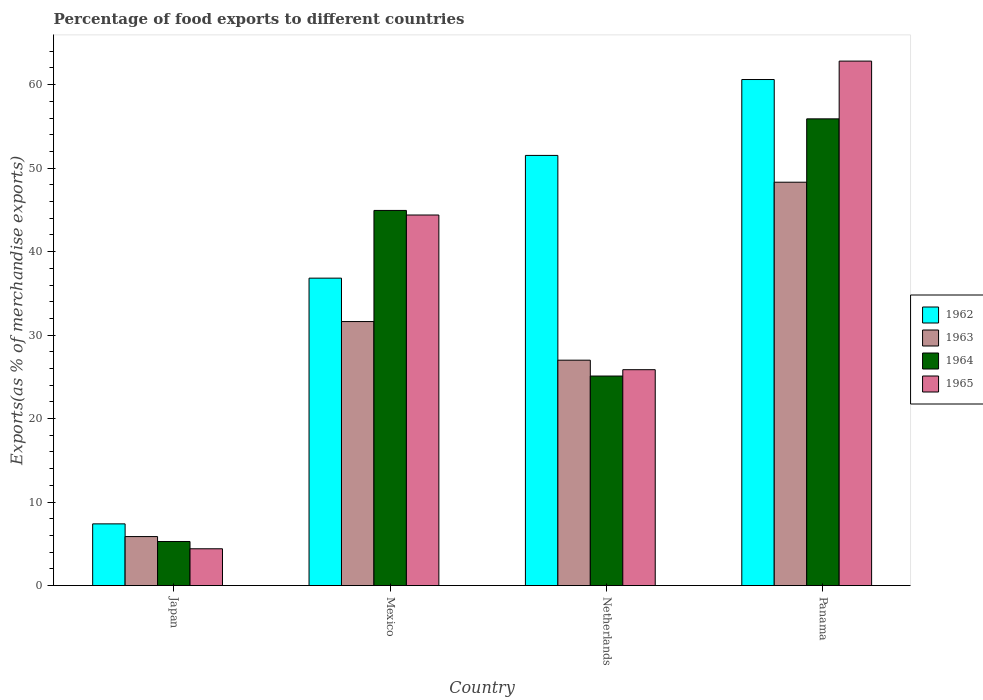Are the number of bars per tick equal to the number of legend labels?
Your answer should be compact. Yes. How many bars are there on the 4th tick from the left?
Keep it short and to the point. 4. In how many cases, is the number of bars for a given country not equal to the number of legend labels?
Offer a very short reply. 0. What is the percentage of exports to different countries in 1964 in Panama?
Your answer should be compact. 55.9. Across all countries, what is the maximum percentage of exports to different countries in 1965?
Offer a terse response. 62.82. Across all countries, what is the minimum percentage of exports to different countries in 1962?
Provide a succinct answer. 7.39. In which country was the percentage of exports to different countries in 1965 maximum?
Provide a short and direct response. Panama. What is the total percentage of exports to different countries in 1963 in the graph?
Your answer should be compact. 112.81. What is the difference between the percentage of exports to different countries in 1964 in Mexico and that in Panama?
Make the answer very short. -10.97. What is the difference between the percentage of exports to different countries in 1962 in Japan and the percentage of exports to different countries in 1964 in Mexico?
Give a very brief answer. -37.55. What is the average percentage of exports to different countries in 1965 per country?
Offer a terse response. 34.37. What is the difference between the percentage of exports to different countries of/in 1963 and percentage of exports to different countries of/in 1964 in Mexico?
Ensure brevity in your answer.  -13.31. What is the ratio of the percentage of exports to different countries in 1963 in Japan to that in Mexico?
Keep it short and to the point. 0.19. What is the difference between the highest and the second highest percentage of exports to different countries in 1962?
Keep it short and to the point. -9.09. What is the difference between the highest and the lowest percentage of exports to different countries in 1965?
Your answer should be very brief. 58.42. Is the sum of the percentage of exports to different countries in 1964 in Japan and Panama greater than the maximum percentage of exports to different countries in 1962 across all countries?
Ensure brevity in your answer.  Yes. Is it the case that in every country, the sum of the percentage of exports to different countries in 1964 and percentage of exports to different countries in 1962 is greater than the sum of percentage of exports to different countries in 1963 and percentage of exports to different countries in 1965?
Keep it short and to the point. No. What does the 3rd bar from the left in Netherlands represents?
Your answer should be compact. 1964. What does the 2nd bar from the right in Mexico represents?
Offer a very short reply. 1964. Is it the case that in every country, the sum of the percentage of exports to different countries in 1964 and percentage of exports to different countries in 1963 is greater than the percentage of exports to different countries in 1962?
Offer a very short reply. Yes. How many bars are there?
Provide a short and direct response. 16. Are all the bars in the graph horizontal?
Give a very brief answer. No. How many countries are there in the graph?
Offer a very short reply. 4. Are the values on the major ticks of Y-axis written in scientific E-notation?
Make the answer very short. No. Does the graph contain any zero values?
Make the answer very short. No. Where does the legend appear in the graph?
Offer a terse response. Center right. How many legend labels are there?
Your response must be concise. 4. What is the title of the graph?
Provide a short and direct response. Percentage of food exports to different countries. What is the label or title of the Y-axis?
Keep it short and to the point. Exports(as % of merchandise exports). What is the Exports(as % of merchandise exports) in 1962 in Japan?
Offer a very short reply. 7.39. What is the Exports(as % of merchandise exports) of 1963 in Japan?
Your answer should be compact. 5.87. What is the Exports(as % of merchandise exports) in 1964 in Japan?
Make the answer very short. 5.28. What is the Exports(as % of merchandise exports) in 1965 in Japan?
Provide a short and direct response. 4.41. What is the Exports(as % of merchandise exports) of 1962 in Mexico?
Your answer should be very brief. 36.82. What is the Exports(as % of merchandise exports) of 1963 in Mexico?
Ensure brevity in your answer.  31.62. What is the Exports(as % of merchandise exports) of 1964 in Mexico?
Keep it short and to the point. 44.93. What is the Exports(as % of merchandise exports) of 1965 in Mexico?
Keep it short and to the point. 44.39. What is the Exports(as % of merchandise exports) of 1962 in Netherlands?
Your answer should be very brief. 51.52. What is the Exports(as % of merchandise exports) of 1963 in Netherlands?
Offer a terse response. 27. What is the Exports(as % of merchandise exports) in 1964 in Netherlands?
Make the answer very short. 25.1. What is the Exports(as % of merchandise exports) in 1965 in Netherlands?
Keep it short and to the point. 25.86. What is the Exports(as % of merchandise exports) in 1962 in Panama?
Make the answer very short. 60.62. What is the Exports(as % of merchandise exports) in 1963 in Panama?
Your response must be concise. 48.32. What is the Exports(as % of merchandise exports) in 1964 in Panama?
Provide a short and direct response. 55.9. What is the Exports(as % of merchandise exports) in 1965 in Panama?
Give a very brief answer. 62.82. Across all countries, what is the maximum Exports(as % of merchandise exports) of 1962?
Make the answer very short. 60.62. Across all countries, what is the maximum Exports(as % of merchandise exports) of 1963?
Make the answer very short. 48.32. Across all countries, what is the maximum Exports(as % of merchandise exports) in 1964?
Keep it short and to the point. 55.9. Across all countries, what is the maximum Exports(as % of merchandise exports) in 1965?
Keep it short and to the point. 62.82. Across all countries, what is the minimum Exports(as % of merchandise exports) of 1962?
Your response must be concise. 7.39. Across all countries, what is the minimum Exports(as % of merchandise exports) of 1963?
Make the answer very short. 5.87. Across all countries, what is the minimum Exports(as % of merchandise exports) of 1964?
Give a very brief answer. 5.28. Across all countries, what is the minimum Exports(as % of merchandise exports) in 1965?
Provide a short and direct response. 4.41. What is the total Exports(as % of merchandise exports) in 1962 in the graph?
Provide a succinct answer. 156.35. What is the total Exports(as % of merchandise exports) in 1963 in the graph?
Offer a very short reply. 112.81. What is the total Exports(as % of merchandise exports) of 1964 in the graph?
Provide a short and direct response. 131.22. What is the total Exports(as % of merchandise exports) in 1965 in the graph?
Provide a short and direct response. 137.47. What is the difference between the Exports(as % of merchandise exports) of 1962 in Japan and that in Mexico?
Offer a very short reply. -29.43. What is the difference between the Exports(as % of merchandise exports) of 1963 in Japan and that in Mexico?
Your response must be concise. -25.75. What is the difference between the Exports(as % of merchandise exports) of 1964 in Japan and that in Mexico?
Your answer should be very brief. -39.66. What is the difference between the Exports(as % of merchandise exports) of 1965 in Japan and that in Mexico?
Provide a succinct answer. -39.98. What is the difference between the Exports(as % of merchandise exports) of 1962 in Japan and that in Netherlands?
Give a very brief answer. -44.13. What is the difference between the Exports(as % of merchandise exports) in 1963 in Japan and that in Netherlands?
Your answer should be very brief. -21.13. What is the difference between the Exports(as % of merchandise exports) of 1964 in Japan and that in Netherlands?
Ensure brevity in your answer.  -19.82. What is the difference between the Exports(as % of merchandise exports) of 1965 in Japan and that in Netherlands?
Your response must be concise. -21.45. What is the difference between the Exports(as % of merchandise exports) of 1962 in Japan and that in Panama?
Your answer should be very brief. -53.23. What is the difference between the Exports(as % of merchandise exports) of 1963 in Japan and that in Panama?
Your answer should be very brief. -42.45. What is the difference between the Exports(as % of merchandise exports) in 1964 in Japan and that in Panama?
Your answer should be very brief. -50.63. What is the difference between the Exports(as % of merchandise exports) in 1965 in Japan and that in Panama?
Give a very brief answer. -58.42. What is the difference between the Exports(as % of merchandise exports) of 1962 in Mexico and that in Netherlands?
Provide a succinct answer. -14.7. What is the difference between the Exports(as % of merchandise exports) in 1963 in Mexico and that in Netherlands?
Your answer should be very brief. 4.63. What is the difference between the Exports(as % of merchandise exports) of 1964 in Mexico and that in Netherlands?
Your response must be concise. 19.84. What is the difference between the Exports(as % of merchandise exports) of 1965 in Mexico and that in Netherlands?
Your answer should be compact. 18.53. What is the difference between the Exports(as % of merchandise exports) of 1962 in Mexico and that in Panama?
Keep it short and to the point. -23.79. What is the difference between the Exports(as % of merchandise exports) of 1963 in Mexico and that in Panama?
Your response must be concise. -16.69. What is the difference between the Exports(as % of merchandise exports) in 1964 in Mexico and that in Panama?
Your answer should be very brief. -10.97. What is the difference between the Exports(as % of merchandise exports) in 1965 in Mexico and that in Panama?
Your answer should be compact. -18.44. What is the difference between the Exports(as % of merchandise exports) in 1962 in Netherlands and that in Panama?
Your answer should be very brief. -9.09. What is the difference between the Exports(as % of merchandise exports) of 1963 in Netherlands and that in Panama?
Offer a very short reply. -21.32. What is the difference between the Exports(as % of merchandise exports) in 1964 in Netherlands and that in Panama?
Give a very brief answer. -30.81. What is the difference between the Exports(as % of merchandise exports) in 1965 in Netherlands and that in Panama?
Give a very brief answer. -36.96. What is the difference between the Exports(as % of merchandise exports) of 1962 in Japan and the Exports(as % of merchandise exports) of 1963 in Mexico?
Provide a succinct answer. -24.23. What is the difference between the Exports(as % of merchandise exports) of 1962 in Japan and the Exports(as % of merchandise exports) of 1964 in Mexico?
Your response must be concise. -37.55. What is the difference between the Exports(as % of merchandise exports) of 1962 in Japan and the Exports(as % of merchandise exports) of 1965 in Mexico?
Ensure brevity in your answer.  -37. What is the difference between the Exports(as % of merchandise exports) of 1963 in Japan and the Exports(as % of merchandise exports) of 1964 in Mexico?
Your answer should be very brief. -39.07. What is the difference between the Exports(as % of merchandise exports) of 1963 in Japan and the Exports(as % of merchandise exports) of 1965 in Mexico?
Offer a terse response. -38.52. What is the difference between the Exports(as % of merchandise exports) in 1964 in Japan and the Exports(as % of merchandise exports) in 1965 in Mexico?
Offer a terse response. -39.11. What is the difference between the Exports(as % of merchandise exports) of 1962 in Japan and the Exports(as % of merchandise exports) of 1963 in Netherlands?
Offer a terse response. -19.61. What is the difference between the Exports(as % of merchandise exports) in 1962 in Japan and the Exports(as % of merchandise exports) in 1964 in Netherlands?
Provide a succinct answer. -17.71. What is the difference between the Exports(as % of merchandise exports) in 1962 in Japan and the Exports(as % of merchandise exports) in 1965 in Netherlands?
Give a very brief answer. -18.47. What is the difference between the Exports(as % of merchandise exports) in 1963 in Japan and the Exports(as % of merchandise exports) in 1964 in Netherlands?
Keep it short and to the point. -19.23. What is the difference between the Exports(as % of merchandise exports) of 1963 in Japan and the Exports(as % of merchandise exports) of 1965 in Netherlands?
Provide a short and direct response. -19.99. What is the difference between the Exports(as % of merchandise exports) in 1964 in Japan and the Exports(as % of merchandise exports) in 1965 in Netherlands?
Your answer should be compact. -20.58. What is the difference between the Exports(as % of merchandise exports) of 1962 in Japan and the Exports(as % of merchandise exports) of 1963 in Panama?
Give a very brief answer. -40.93. What is the difference between the Exports(as % of merchandise exports) of 1962 in Japan and the Exports(as % of merchandise exports) of 1964 in Panama?
Make the answer very short. -48.51. What is the difference between the Exports(as % of merchandise exports) of 1962 in Japan and the Exports(as % of merchandise exports) of 1965 in Panama?
Offer a very short reply. -55.43. What is the difference between the Exports(as % of merchandise exports) of 1963 in Japan and the Exports(as % of merchandise exports) of 1964 in Panama?
Ensure brevity in your answer.  -50.03. What is the difference between the Exports(as % of merchandise exports) in 1963 in Japan and the Exports(as % of merchandise exports) in 1965 in Panama?
Provide a succinct answer. -56.95. What is the difference between the Exports(as % of merchandise exports) of 1964 in Japan and the Exports(as % of merchandise exports) of 1965 in Panama?
Your response must be concise. -57.54. What is the difference between the Exports(as % of merchandise exports) in 1962 in Mexico and the Exports(as % of merchandise exports) in 1963 in Netherlands?
Give a very brief answer. 9.83. What is the difference between the Exports(as % of merchandise exports) in 1962 in Mexico and the Exports(as % of merchandise exports) in 1964 in Netherlands?
Your answer should be very brief. 11.72. What is the difference between the Exports(as % of merchandise exports) of 1962 in Mexico and the Exports(as % of merchandise exports) of 1965 in Netherlands?
Your answer should be compact. 10.96. What is the difference between the Exports(as % of merchandise exports) of 1963 in Mexico and the Exports(as % of merchandise exports) of 1964 in Netherlands?
Make the answer very short. 6.53. What is the difference between the Exports(as % of merchandise exports) in 1963 in Mexico and the Exports(as % of merchandise exports) in 1965 in Netherlands?
Offer a terse response. 5.77. What is the difference between the Exports(as % of merchandise exports) of 1964 in Mexico and the Exports(as % of merchandise exports) of 1965 in Netherlands?
Your response must be concise. 19.08. What is the difference between the Exports(as % of merchandise exports) of 1962 in Mexico and the Exports(as % of merchandise exports) of 1963 in Panama?
Keep it short and to the point. -11.49. What is the difference between the Exports(as % of merchandise exports) of 1962 in Mexico and the Exports(as % of merchandise exports) of 1964 in Panama?
Provide a succinct answer. -19.08. What is the difference between the Exports(as % of merchandise exports) in 1962 in Mexico and the Exports(as % of merchandise exports) in 1965 in Panama?
Your answer should be very brief. -26. What is the difference between the Exports(as % of merchandise exports) in 1963 in Mexico and the Exports(as % of merchandise exports) in 1964 in Panama?
Offer a terse response. -24.28. What is the difference between the Exports(as % of merchandise exports) in 1963 in Mexico and the Exports(as % of merchandise exports) in 1965 in Panama?
Offer a very short reply. -31.2. What is the difference between the Exports(as % of merchandise exports) in 1964 in Mexico and the Exports(as % of merchandise exports) in 1965 in Panama?
Your response must be concise. -17.89. What is the difference between the Exports(as % of merchandise exports) of 1962 in Netherlands and the Exports(as % of merchandise exports) of 1963 in Panama?
Keep it short and to the point. 3.21. What is the difference between the Exports(as % of merchandise exports) in 1962 in Netherlands and the Exports(as % of merchandise exports) in 1964 in Panama?
Your answer should be very brief. -4.38. What is the difference between the Exports(as % of merchandise exports) in 1962 in Netherlands and the Exports(as % of merchandise exports) in 1965 in Panama?
Give a very brief answer. -11.3. What is the difference between the Exports(as % of merchandise exports) in 1963 in Netherlands and the Exports(as % of merchandise exports) in 1964 in Panama?
Provide a succinct answer. -28.91. What is the difference between the Exports(as % of merchandise exports) of 1963 in Netherlands and the Exports(as % of merchandise exports) of 1965 in Panama?
Offer a terse response. -35.82. What is the difference between the Exports(as % of merchandise exports) in 1964 in Netherlands and the Exports(as % of merchandise exports) in 1965 in Panama?
Provide a short and direct response. -37.72. What is the average Exports(as % of merchandise exports) in 1962 per country?
Offer a terse response. 39.09. What is the average Exports(as % of merchandise exports) in 1963 per country?
Provide a succinct answer. 28.2. What is the average Exports(as % of merchandise exports) in 1964 per country?
Keep it short and to the point. 32.8. What is the average Exports(as % of merchandise exports) of 1965 per country?
Your answer should be compact. 34.37. What is the difference between the Exports(as % of merchandise exports) in 1962 and Exports(as % of merchandise exports) in 1963 in Japan?
Keep it short and to the point. 1.52. What is the difference between the Exports(as % of merchandise exports) of 1962 and Exports(as % of merchandise exports) of 1964 in Japan?
Your answer should be compact. 2.11. What is the difference between the Exports(as % of merchandise exports) in 1962 and Exports(as % of merchandise exports) in 1965 in Japan?
Provide a short and direct response. 2.98. What is the difference between the Exports(as % of merchandise exports) of 1963 and Exports(as % of merchandise exports) of 1964 in Japan?
Give a very brief answer. 0.59. What is the difference between the Exports(as % of merchandise exports) of 1963 and Exports(as % of merchandise exports) of 1965 in Japan?
Offer a terse response. 1.46. What is the difference between the Exports(as % of merchandise exports) of 1964 and Exports(as % of merchandise exports) of 1965 in Japan?
Ensure brevity in your answer.  0.87. What is the difference between the Exports(as % of merchandise exports) of 1962 and Exports(as % of merchandise exports) of 1963 in Mexico?
Keep it short and to the point. 5.2. What is the difference between the Exports(as % of merchandise exports) in 1962 and Exports(as % of merchandise exports) in 1964 in Mexico?
Provide a short and direct response. -8.11. What is the difference between the Exports(as % of merchandise exports) of 1962 and Exports(as % of merchandise exports) of 1965 in Mexico?
Your answer should be very brief. -7.56. What is the difference between the Exports(as % of merchandise exports) in 1963 and Exports(as % of merchandise exports) in 1964 in Mexico?
Provide a short and direct response. -13.31. What is the difference between the Exports(as % of merchandise exports) of 1963 and Exports(as % of merchandise exports) of 1965 in Mexico?
Offer a terse response. -12.76. What is the difference between the Exports(as % of merchandise exports) in 1964 and Exports(as % of merchandise exports) in 1965 in Mexico?
Your answer should be compact. 0.55. What is the difference between the Exports(as % of merchandise exports) of 1962 and Exports(as % of merchandise exports) of 1963 in Netherlands?
Give a very brief answer. 24.53. What is the difference between the Exports(as % of merchandise exports) of 1962 and Exports(as % of merchandise exports) of 1964 in Netherlands?
Provide a succinct answer. 26.43. What is the difference between the Exports(as % of merchandise exports) of 1962 and Exports(as % of merchandise exports) of 1965 in Netherlands?
Your answer should be compact. 25.67. What is the difference between the Exports(as % of merchandise exports) of 1963 and Exports(as % of merchandise exports) of 1964 in Netherlands?
Your response must be concise. 1.9. What is the difference between the Exports(as % of merchandise exports) in 1963 and Exports(as % of merchandise exports) in 1965 in Netherlands?
Offer a very short reply. 1.14. What is the difference between the Exports(as % of merchandise exports) of 1964 and Exports(as % of merchandise exports) of 1965 in Netherlands?
Make the answer very short. -0.76. What is the difference between the Exports(as % of merchandise exports) of 1962 and Exports(as % of merchandise exports) of 1963 in Panama?
Offer a terse response. 12.3. What is the difference between the Exports(as % of merchandise exports) in 1962 and Exports(as % of merchandise exports) in 1964 in Panama?
Give a very brief answer. 4.71. What is the difference between the Exports(as % of merchandise exports) of 1962 and Exports(as % of merchandise exports) of 1965 in Panama?
Offer a very short reply. -2.21. What is the difference between the Exports(as % of merchandise exports) in 1963 and Exports(as % of merchandise exports) in 1964 in Panama?
Keep it short and to the point. -7.59. What is the difference between the Exports(as % of merchandise exports) of 1963 and Exports(as % of merchandise exports) of 1965 in Panama?
Offer a very short reply. -14.51. What is the difference between the Exports(as % of merchandise exports) in 1964 and Exports(as % of merchandise exports) in 1965 in Panama?
Your answer should be compact. -6.92. What is the ratio of the Exports(as % of merchandise exports) of 1962 in Japan to that in Mexico?
Give a very brief answer. 0.2. What is the ratio of the Exports(as % of merchandise exports) in 1963 in Japan to that in Mexico?
Your response must be concise. 0.19. What is the ratio of the Exports(as % of merchandise exports) of 1964 in Japan to that in Mexico?
Ensure brevity in your answer.  0.12. What is the ratio of the Exports(as % of merchandise exports) of 1965 in Japan to that in Mexico?
Your response must be concise. 0.1. What is the ratio of the Exports(as % of merchandise exports) of 1962 in Japan to that in Netherlands?
Ensure brevity in your answer.  0.14. What is the ratio of the Exports(as % of merchandise exports) of 1963 in Japan to that in Netherlands?
Your response must be concise. 0.22. What is the ratio of the Exports(as % of merchandise exports) of 1964 in Japan to that in Netherlands?
Your response must be concise. 0.21. What is the ratio of the Exports(as % of merchandise exports) of 1965 in Japan to that in Netherlands?
Provide a succinct answer. 0.17. What is the ratio of the Exports(as % of merchandise exports) in 1962 in Japan to that in Panama?
Your answer should be very brief. 0.12. What is the ratio of the Exports(as % of merchandise exports) in 1963 in Japan to that in Panama?
Your response must be concise. 0.12. What is the ratio of the Exports(as % of merchandise exports) of 1964 in Japan to that in Panama?
Provide a succinct answer. 0.09. What is the ratio of the Exports(as % of merchandise exports) of 1965 in Japan to that in Panama?
Your answer should be very brief. 0.07. What is the ratio of the Exports(as % of merchandise exports) in 1962 in Mexico to that in Netherlands?
Make the answer very short. 0.71. What is the ratio of the Exports(as % of merchandise exports) of 1963 in Mexico to that in Netherlands?
Your answer should be compact. 1.17. What is the ratio of the Exports(as % of merchandise exports) of 1964 in Mexico to that in Netherlands?
Your response must be concise. 1.79. What is the ratio of the Exports(as % of merchandise exports) of 1965 in Mexico to that in Netherlands?
Your response must be concise. 1.72. What is the ratio of the Exports(as % of merchandise exports) of 1962 in Mexico to that in Panama?
Your answer should be compact. 0.61. What is the ratio of the Exports(as % of merchandise exports) of 1963 in Mexico to that in Panama?
Make the answer very short. 0.65. What is the ratio of the Exports(as % of merchandise exports) of 1964 in Mexico to that in Panama?
Provide a short and direct response. 0.8. What is the ratio of the Exports(as % of merchandise exports) in 1965 in Mexico to that in Panama?
Keep it short and to the point. 0.71. What is the ratio of the Exports(as % of merchandise exports) in 1963 in Netherlands to that in Panama?
Ensure brevity in your answer.  0.56. What is the ratio of the Exports(as % of merchandise exports) in 1964 in Netherlands to that in Panama?
Offer a very short reply. 0.45. What is the ratio of the Exports(as % of merchandise exports) in 1965 in Netherlands to that in Panama?
Offer a terse response. 0.41. What is the difference between the highest and the second highest Exports(as % of merchandise exports) of 1962?
Offer a terse response. 9.09. What is the difference between the highest and the second highest Exports(as % of merchandise exports) in 1963?
Provide a short and direct response. 16.69. What is the difference between the highest and the second highest Exports(as % of merchandise exports) of 1964?
Your response must be concise. 10.97. What is the difference between the highest and the second highest Exports(as % of merchandise exports) of 1965?
Give a very brief answer. 18.44. What is the difference between the highest and the lowest Exports(as % of merchandise exports) in 1962?
Your response must be concise. 53.23. What is the difference between the highest and the lowest Exports(as % of merchandise exports) of 1963?
Provide a succinct answer. 42.45. What is the difference between the highest and the lowest Exports(as % of merchandise exports) of 1964?
Keep it short and to the point. 50.63. What is the difference between the highest and the lowest Exports(as % of merchandise exports) in 1965?
Provide a short and direct response. 58.42. 